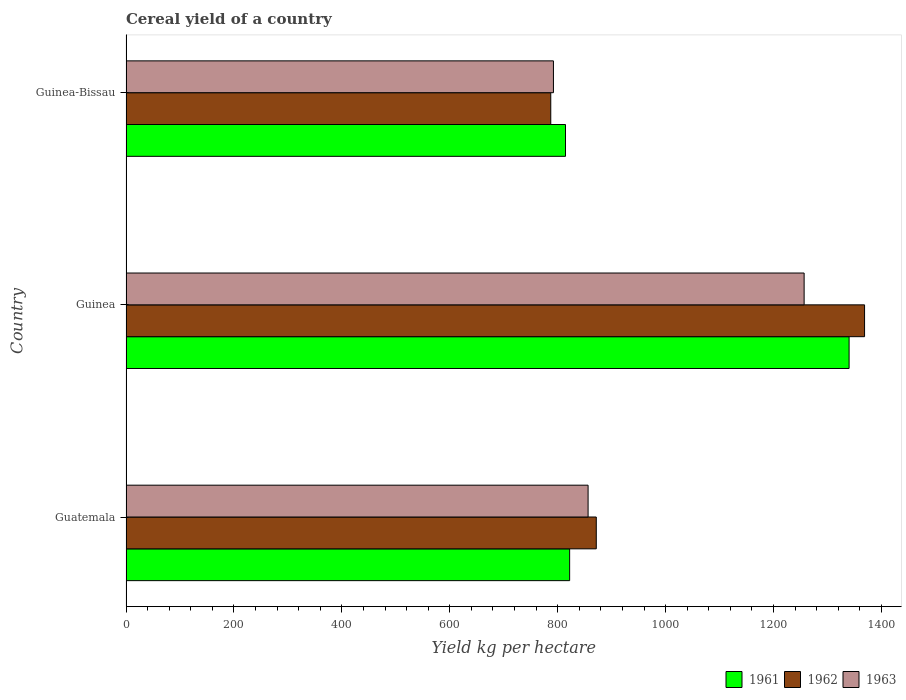How many different coloured bars are there?
Your answer should be compact. 3. How many groups of bars are there?
Your answer should be very brief. 3. Are the number of bars per tick equal to the number of legend labels?
Ensure brevity in your answer.  Yes. Are the number of bars on each tick of the Y-axis equal?
Ensure brevity in your answer.  Yes. How many bars are there on the 3rd tick from the bottom?
Offer a very short reply. 3. What is the label of the 3rd group of bars from the top?
Ensure brevity in your answer.  Guatemala. What is the total cereal yield in 1962 in Guinea-Bissau?
Ensure brevity in your answer.  787.13. Across all countries, what is the maximum total cereal yield in 1963?
Provide a succinct answer. 1256.66. Across all countries, what is the minimum total cereal yield in 1961?
Your response must be concise. 814.43. In which country was the total cereal yield in 1961 maximum?
Ensure brevity in your answer.  Guinea. In which country was the total cereal yield in 1963 minimum?
Provide a succinct answer. Guinea-Bissau. What is the total total cereal yield in 1962 in the graph?
Keep it short and to the point. 3027.27. What is the difference between the total cereal yield in 1961 in Guinea and that in Guinea-Bissau?
Keep it short and to the point. 525.57. What is the difference between the total cereal yield in 1961 in Guatemala and the total cereal yield in 1962 in Guinea?
Keep it short and to the point. -546.54. What is the average total cereal yield in 1962 per country?
Provide a succinct answer. 1009.09. What is the difference between the total cereal yield in 1963 and total cereal yield in 1962 in Guatemala?
Provide a succinct answer. -15.19. In how many countries, is the total cereal yield in 1962 greater than 1200 kg per hectare?
Offer a very short reply. 1. What is the ratio of the total cereal yield in 1963 in Guatemala to that in Guinea?
Your response must be concise. 0.68. Is the difference between the total cereal yield in 1963 in Guatemala and Guinea-Bissau greater than the difference between the total cereal yield in 1962 in Guatemala and Guinea-Bissau?
Your response must be concise. No. What is the difference between the highest and the second highest total cereal yield in 1962?
Your answer should be compact. 497.17. What is the difference between the highest and the lowest total cereal yield in 1963?
Offer a terse response. 464.59. How many bars are there?
Make the answer very short. 9. Are all the bars in the graph horizontal?
Make the answer very short. Yes. How many countries are there in the graph?
Make the answer very short. 3. What is the difference between two consecutive major ticks on the X-axis?
Your response must be concise. 200. Does the graph contain any zero values?
Provide a succinct answer. No. Where does the legend appear in the graph?
Provide a short and direct response. Bottom right. How are the legend labels stacked?
Provide a succinct answer. Horizontal. What is the title of the graph?
Keep it short and to the point. Cereal yield of a country. What is the label or title of the X-axis?
Offer a terse response. Yield kg per hectare. What is the label or title of the Y-axis?
Keep it short and to the point. Country. What is the Yield kg per hectare in 1961 in Guatemala?
Provide a succinct answer. 822.12. What is the Yield kg per hectare in 1962 in Guatemala?
Your response must be concise. 871.48. What is the Yield kg per hectare in 1963 in Guatemala?
Keep it short and to the point. 856.3. What is the Yield kg per hectare in 1961 in Guinea?
Provide a short and direct response. 1340. What is the Yield kg per hectare of 1962 in Guinea?
Keep it short and to the point. 1368.66. What is the Yield kg per hectare in 1963 in Guinea?
Ensure brevity in your answer.  1256.66. What is the Yield kg per hectare in 1961 in Guinea-Bissau?
Ensure brevity in your answer.  814.43. What is the Yield kg per hectare in 1962 in Guinea-Bissau?
Your answer should be compact. 787.13. What is the Yield kg per hectare in 1963 in Guinea-Bissau?
Make the answer very short. 792.08. Across all countries, what is the maximum Yield kg per hectare in 1961?
Your response must be concise. 1340. Across all countries, what is the maximum Yield kg per hectare of 1962?
Your response must be concise. 1368.66. Across all countries, what is the maximum Yield kg per hectare in 1963?
Your response must be concise. 1256.66. Across all countries, what is the minimum Yield kg per hectare in 1961?
Your answer should be very brief. 814.43. Across all countries, what is the minimum Yield kg per hectare of 1962?
Ensure brevity in your answer.  787.13. Across all countries, what is the minimum Yield kg per hectare of 1963?
Make the answer very short. 792.08. What is the total Yield kg per hectare of 1961 in the graph?
Provide a short and direct response. 2976.55. What is the total Yield kg per hectare of 1962 in the graph?
Your answer should be very brief. 3027.27. What is the total Yield kg per hectare of 1963 in the graph?
Ensure brevity in your answer.  2905.04. What is the difference between the Yield kg per hectare of 1961 in Guatemala and that in Guinea?
Give a very brief answer. -517.88. What is the difference between the Yield kg per hectare in 1962 in Guatemala and that in Guinea?
Provide a succinct answer. -497.17. What is the difference between the Yield kg per hectare in 1963 in Guatemala and that in Guinea?
Provide a succinct answer. -400.37. What is the difference between the Yield kg per hectare of 1961 in Guatemala and that in Guinea-Bissau?
Offer a very short reply. 7.68. What is the difference between the Yield kg per hectare in 1962 in Guatemala and that in Guinea-Bissau?
Offer a terse response. 84.35. What is the difference between the Yield kg per hectare in 1963 in Guatemala and that in Guinea-Bissau?
Make the answer very short. 64.22. What is the difference between the Yield kg per hectare of 1961 in Guinea and that in Guinea-Bissau?
Keep it short and to the point. 525.57. What is the difference between the Yield kg per hectare of 1962 in Guinea and that in Guinea-Bissau?
Your answer should be very brief. 581.53. What is the difference between the Yield kg per hectare in 1963 in Guinea and that in Guinea-Bissau?
Ensure brevity in your answer.  464.59. What is the difference between the Yield kg per hectare of 1961 in Guatemala and the Yield kg per hectare of 1962 in Guinea?
Provide a succinct answer. -546.54. What is the difference between the Yield kg per hectare of 1961 in Guatemala and the Yield kg per hectare of 1963 in Guinea?
Your answer should be compact. -434.55. What is the difference between the Yield kg per hectare in 1962 in Guatemala and the Yield kg per hectare in 1963 in Guinea?
Your answer should be very brief. -385.18. What is the difference between the Yield kg per hectare in 1961 in Guatemala and the Yield kg per hectare in 1962 in Guinea-Bissau?
Keep it short and to the point. 34.99. What is the difference between the Yield kg per hectare of 1961 in Guatemala and the Yield kg per hectare of 1963 in Guinea-Bissau?
Give a very brief answer. 30.04. What is the difference between the Yield kg per hectare of 1962 in Guatemala and the Yield kg per hectare of 1963 in Guinea-Bissau?
Your response must be concise. 79.4. What is the difference between the Yield kg per hectare of 1961 in Guinea and the Yield kg per hectare of 1962 in Guinea-Bissau?
Your response must be concise. 552.87. What is the difference between the Yield kg per hectare of 1961 in Guinea and the Yield kg per hectare of 1963 in Guinea-Bissau?
Your answer should be compact. 547.92. What is the difference between the Yield kg per hectare of 1962 in Guinea and the Yield kg per hectare of 1963 in Guinea-Bissau?
Your answer should be compact. 576.58. What is the average Yield kg per hectare in 1961 per country?
Keep it short and to the point. 992.18. What is the average Yield kg per hectare in 1962 per country?
Give a very brief answer. 1009.09. What is the average Yield kg per hectare of 1963 per country?
Provide a short and direct response. 968.35. What is the difference between the Yield kg per hectare of 1961 and Yield kg per hectare of 1962 in Guatemala?
Give a very brief answer. -49.37. What is the difference between the Yield kg per hectare in 1961 and Yield kg per hectare in 1963 in Guatemala?
Offer a terse response. -34.18. What is the difference between the Yield kg per hectare in 1962 and Yield kg per hectare in 1963 in Guatemala?
Provide a succinct answer. 15.19. What is the difference between the Yield kg per hectare of 1961 and Yield kg per hectare of 1962 in Guinea?
Provide a succinct answer. -28.66. What is the difference between the Yield kg per hectare in 1961 and Yield kg per hectare in 1963 in Guinea?
Offer a very short reply. 83.33. What is the difference between the Yield kg per hectare in 1962 and Yield kg per hectare in 1963 in Guinea?
Make the answer very short. 111.99. What is the difference between the Yield kg per hectare in 1961 and Yield kg per hectare in 1962 in Guinea-Bissau?
Your answer should be very brief. 27.3. What is the difference between the Yield kg per hectare of 1961 and Yield kg per hectare of 1963 in Guinea-Bissau?
Make the answer very short. 22.35. What is the difference between the Yield kg per hectare of 1962 and Yield kg per hectare of 1963 in Guinea-Bissau?
Your response must be concise. -4.95. What is the ratio of the Yield kg per hectare of 1961 in Guatemala to that in Guinea?
Offer a terse response. 0.61. What is the ratio of the Yield kg per hectare in 1962 in Guatemala to that in Guinea?
Make the answer very short. 0.64. What is the ratio of the Yield kg per hectare in 1963 in Guatemala to that in Guinea?
Provide a short and direct response. 0.68. What is the ratio of the Yield kg per hectare in 1961 in Guatemala to that in Guinea-Bissau?
Provide a succinct answer. 1.01. What is the ratio of the Yield kg per hectare of 1962 in Guatemala to that in Guinea-Bissau?
Give a very brief answer. 1.11. What is the ratio of the Yield kg per hectare in 1963 in Guatemala to that in Guinea-Bissau?
Your answer should be compact. 1.08. What is the ratio of the Yield kg per hectare of 1961 in Guinea to that in Guinea-Bissau?
Make the answer very short. 1.65. What is the ratio of the Yield kg per hectare of 1962 in Guinea to that in Guinea-Bissau?
Provide a short and direct response. 1.74. What is the ratio of the Yield kg per hectare of 1963 in Guinea to that in Guinea-Bissau?
Keep it short and to the point. 1.59. What is the difference between the highest and the second highest Yield kg per hectare of 1961?
Provide a short and direct response. 517.88. What is the difference between the highest and the second highest Yield kg per hectare in 1962?
Your response must be concise. 497.17. What is the difference between the highest and the second highest Yield kg per hectare in 1963?
Give a very brief answer. 400.37. What is the difference between the highest and the lowest Yield kg per hectare in 1961?
Your response must be concise. 525.57. What is the difference between the highest and the lowest Yield kg per hectare in 1962?
Ensure brevity in your answer.  581.53. What is the difference between the highest and the lowest Yield kg per hectare of 1963?
Give a very brief answer. 464.59. 